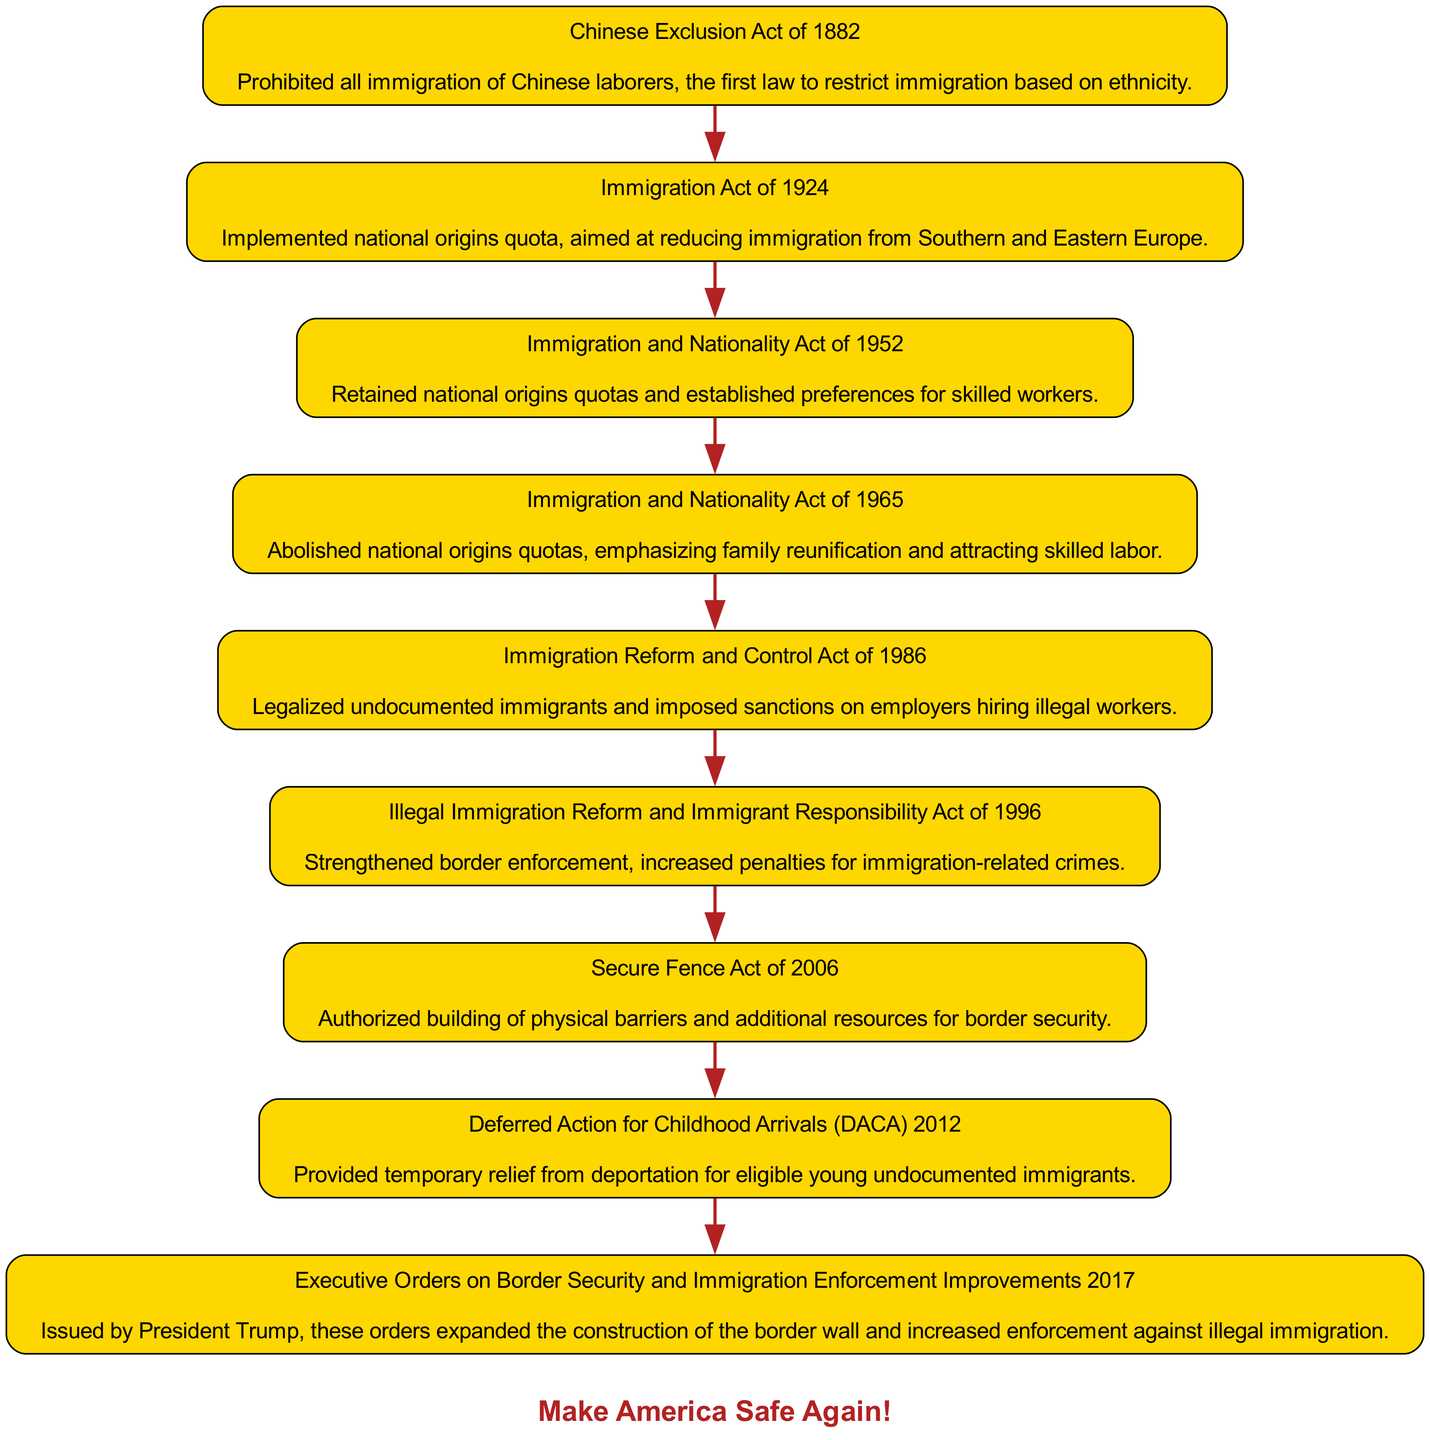What is the first immigration law mentioned in the diagram? The diagram presents a sequence of U.S. immigration policies, and the first one is the Chinese Exclusion Act of 1882, which is at the top of the diagram.
Answer: Chinese Exclusion Act of 1882 How many immigration laws are listed in the diagram? The diagram lists a total of eight immigration laws. Each law represents a significant change in U.S. immigration policy and is connected in sequence.
Answer: Eight What significant change did the Immigration and Nationality Act of 1965 bring about? This act abolished national origins quotas in the U.S., focusing instead on family reunification and attracting skilled labor, which significantly altered the immigration landscape.
Answer: Abolished national origins quotas Which immigration policy strengthened border enforcement? The Illegal Immigration Reform and Immigrant Responsibility Act of 1996 is identified in the diagram as the policy that strengthened border enforcement measures and increased penalties for violations.
Answer: Illegal Immigration Reform and Immigrant Responsibility Act of 1996 What year was the Secure Fence Act enacted? The diagram shows that the Secure Fence Act was enacted in 2006, making it a key part of border security legislation depicted in the timeline.
Answer: 2006 Which U.S. president issued Executive Orders on border security and immigration enforcement improvements? According to the diagram, the Executive Orders were issued by President Trump, indicating a direct link between his administration and these security measures.
Answer: President Trump How did the Immigration Reform and Control Act of 1986 affect undocumented immigrants? This act legalized undocumented immigrants, which is a notable change in U.S. immigration policy recognized in the diagram.
Answer: Legalized undocumented immigrants What is the main focus of the Immigration Act of 1924? According to the diagram, the primary aim of this act was to implement national origins quotas, specifically targeting reductions in immigration from Southern and Eastern Europe.
Answer: National origins quota What phrase is used in the diagram as a patriotic footer? The footer prominently features the phrase "Make America Safe Again!", which aligns with themes of border security and immigration policies emphasized in the diagram.
Answer: Make America Safe Again! 